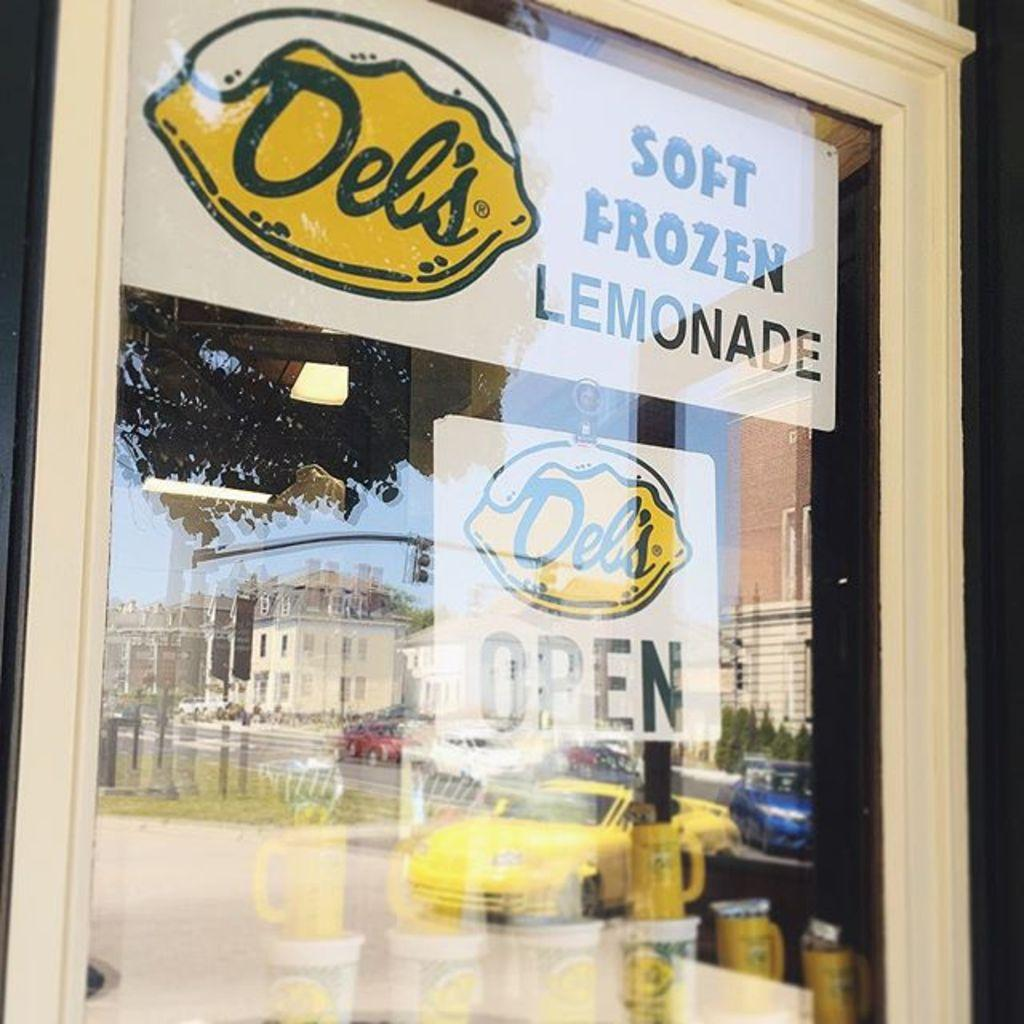Provide a one-sentence caption for the provided image. The store is open and sales soft frozen lemonade. 